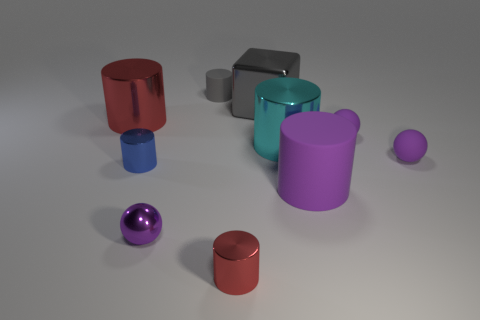Subtract all purple cylinders. How many cylinders are left? 5 Subtract all purple matte spheres. How many spheres are left? 1 Subtract all yellow blocks. How many cyan cylinders are left? 1 Subtract 0 yellow blocks. How many objects are left? 10 Subtract all blocks. How many objects are left? 9 Subtract 1 cubes. How many cubes are left? 0 Subtract all red cylinders. Subtract all brown spheres. How many cylinders are left? 4 Subtract all big purple rubber things. Subtract all large metallic cubes. How many objects are left? 8 Add 9 metal balls. How many metal balls are left? 10 Add 8 blue metal cylinders. How many blue metal cylinders exist? 9 